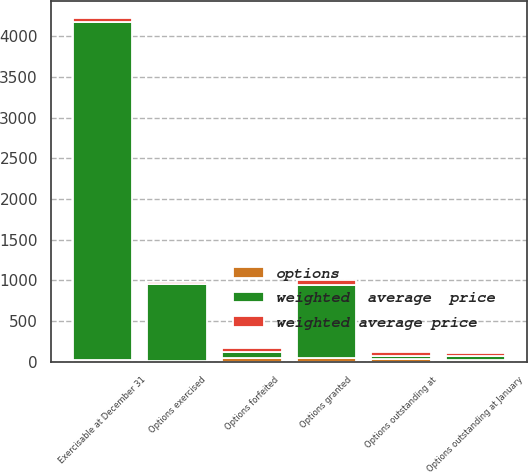Convert chart. <chart><loc_0><loc_0><loc_500><loc_500><stacked_bar_chart><ecel><fcel>Options outstanding at January<fcel>Options granted<fcel>Options exercised<fcel>Options forfeited<fcel>Options outstanding at<fcel>Exercisable at December 31<nl><fcel>weighted  average  price<fcel>42.5<fcel>905<fcel>938<fcel>77<fcel>42.5<fcel>4159<nl><fcel>weighted average price<fcel>41<fcel>60<fcel>33<fcel>51<fcel>45<fcel>40<nl><fcel>options<fcel>27<fcel>41<fcel>16<fcel>44<fcel>31<fcel>23<nl></chart> 